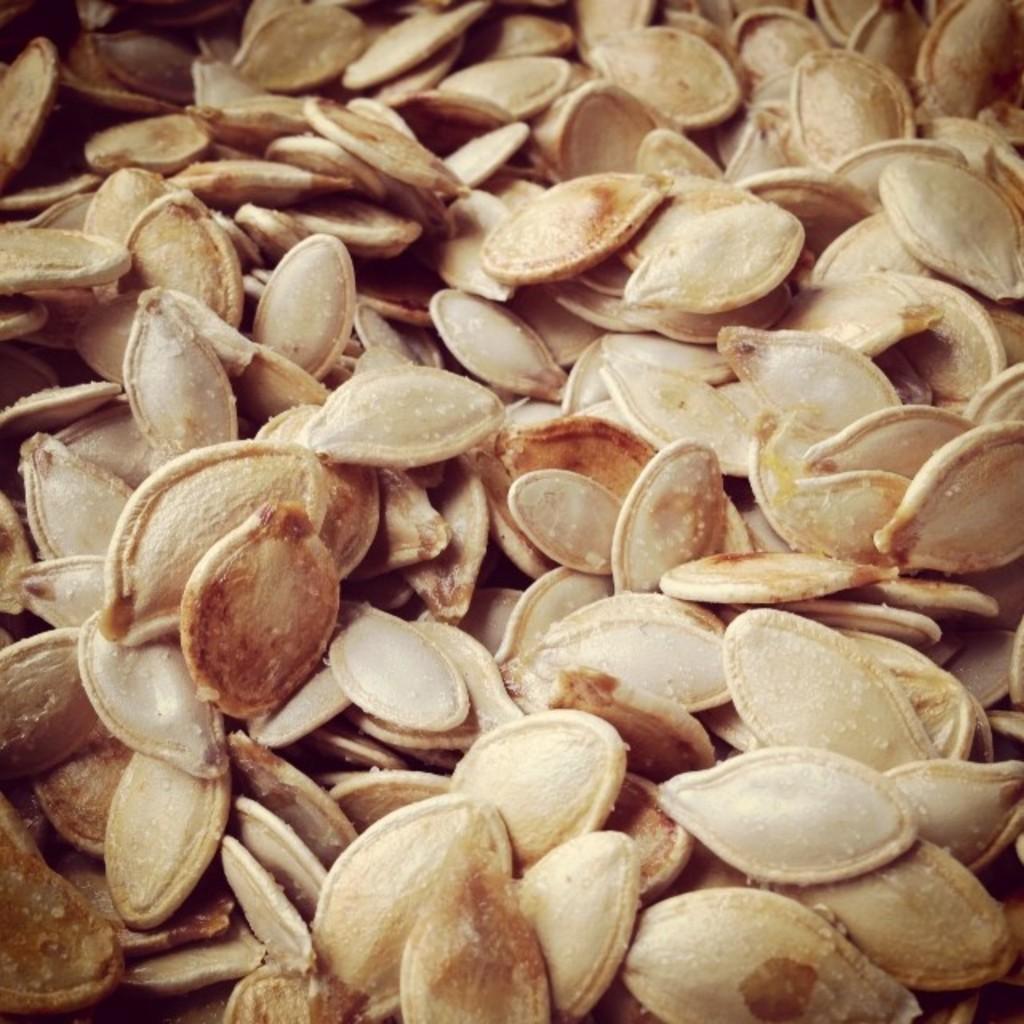In one or two sentences, can you explain what this image depicts? In this image we can see the pumpkin seeds. 